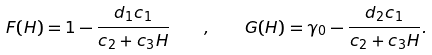<formula> <loc_0><loc_0><loc_500><loc_500>F ( H ) = 1 - \frac { d _ { 1 } c _ { 1 } } { c _ { 2 } + c _ { 3 } H } \quad , \quad G ( H ) = \gamma _ { 0 } - \frac { d _ { 2 } c _ { 1 } } { c _ { 2 } + c _ { 3 } H } .</formula> 